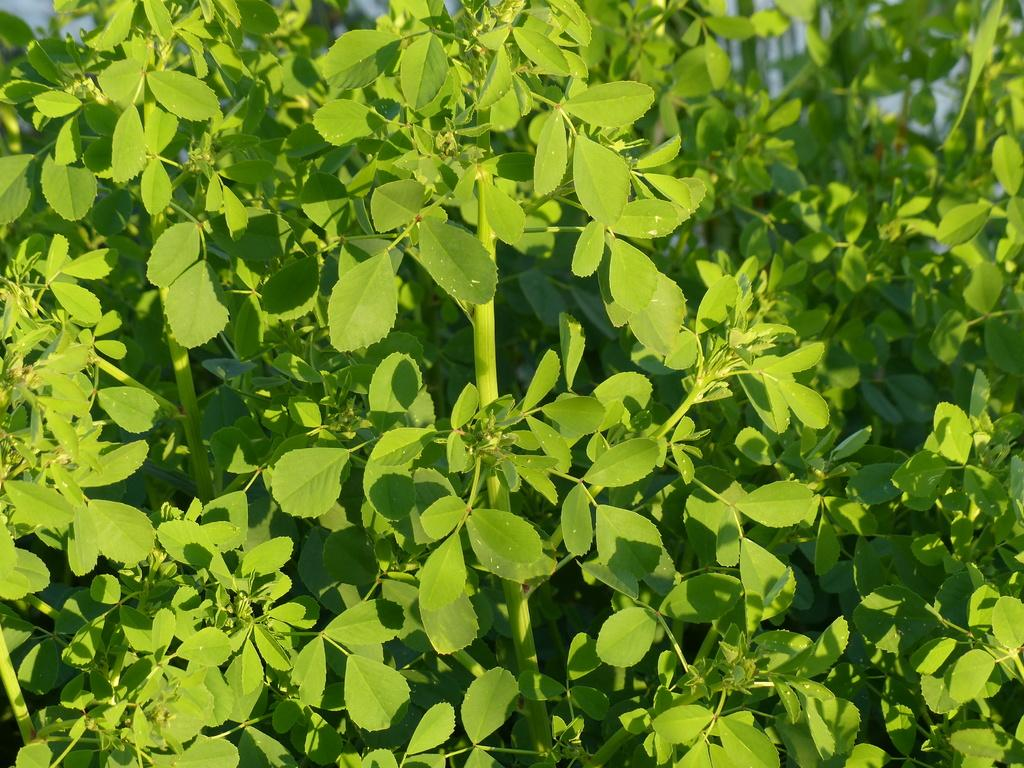What type of vegetation is present in the image? There are green leaves and green stems in the image. Can you describe the color of the vegetation? The vegetation in the image is green. Who is the creator of the water in the image? There is no water present in the image, so it is not possible to determine the creator of any water. 